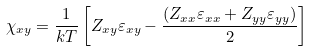Convert formula to latex. <formula><loc_0><loc_0><loc_500><loc_500>\chi _ { x y } = \frac { 1 } { k T } \left [ Z _ { x y } \varepsilon _ { x y } - \frac { ( Z _ { x x } \varepsilon _ { x x } + Z _ { y y } \varepsilon _ { y y } ) } { 2 } \right ]</formula> 